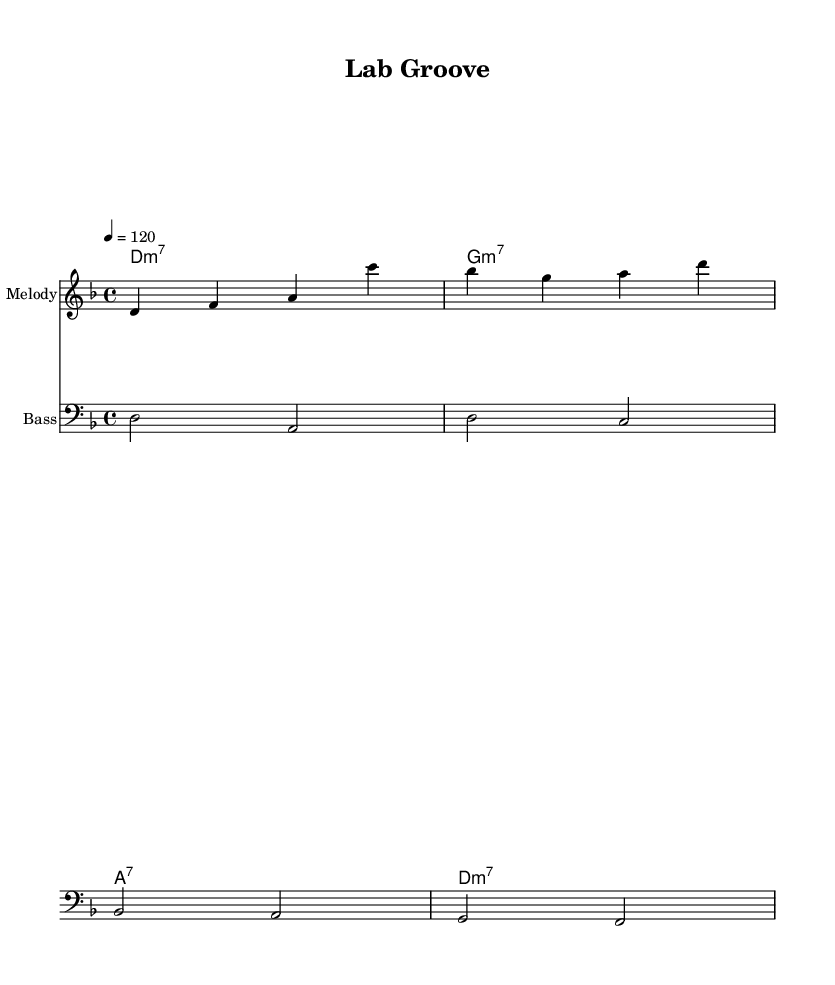What is the key signature of this music? The key signature is D minor, which has one flat (B flat). This information can be identified from the key signature marking at the beginning of the sheet music.
Answer: D minor What is the time signature of this music? The time signature is 4/4, which means there are four beats in each measure and the quarter note gets one beat. This is indicated at the beginning of the music next to the key signature.
Answer: 4/4 What is the tempo marking for this piece? The tempo marking is 120 beats per minute, as shown in the "tempo" directive at the start of the score. This indicates the speed of the piece.
Answer: 120 How many measures are in the melody? The melody consists of four measures, which can be counted from the placement of the barlines throughout the melody section. Each group between two barlines counts as one measure.
Answer: 4 What type of chords are used in the chord names? The chords are primarily seventh chords, specifically minor seventh and dominant seventh chords, as indicated by the chord names provided in the score, which include "m7" and "7".
Answer: seventh chords How do the lyrics reflect the daily life of a medical researcher? The lyrics reference activities relevant to a medical researcher, such as using a microscope and testing hypotheses, which relate directly to data analysis and research practices, demonstrating an everyday experience in the lab.
Answer: daily life of a medical researcher 